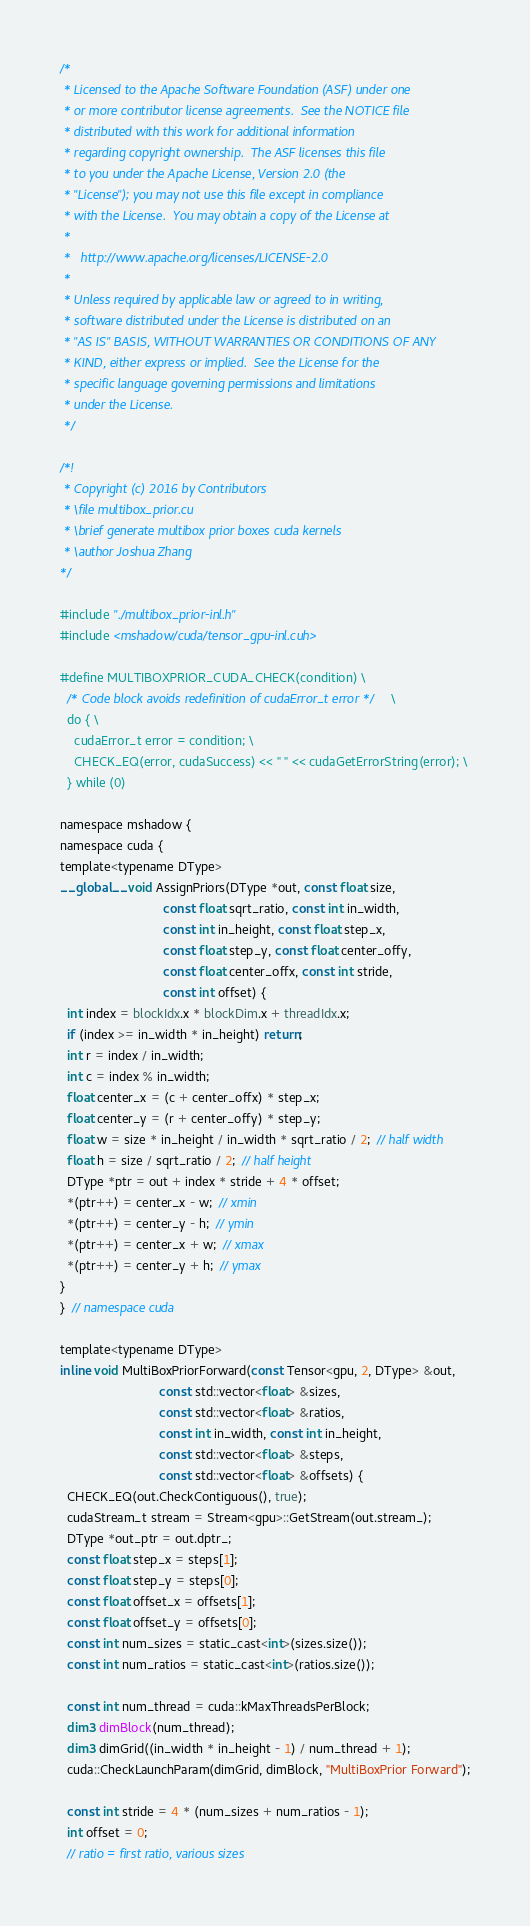Convert code to text. <code><loc_0><loc_0><loc_500><loc_500><_Cuda_>/*
 * Licensed to the Apache Software Foundation (ASF) under one
 * or more contributor license agreements.  See the NOTICE file
 * distributed with this work for additional information
 * regarding copyright ownership.  The ASF licenses this file
 * to you under the Apache License, Version 2.0 (the
 * "License"); you may not use this file except in compliance
 * with the License.  You may obtain a copy of the License at
 *
 *   http://www.apache.org/licenses/LICENSE-2.0
 *
 * Unless required by applicable law or agreed to in writing,
 * software distributed under the License is distributed on an
 * "AS IS" BASIS, WITHOUT WARRANTIES OR CONDITIONS OF ANY
 * KIND, either express or implied.  See the License for the
 * specific language governing permissions and limitations
 * under the License.
 */

/*!
 * Copyright (c) 2016 by Contributors
 * \file multibox_prior.cu
 * \brief generate multibox prior boxes cuda kernels
 * \author Joshua Zhang
*/

#include "./multibox_prior-inl.h"
#include <mshadow/cuda/tensor_gpu-inl.cuh>

#define MULTIBOXPRIOR_CUDA_CHECK(condition) \
  /* Code block avoids redefinition of cudaError_t error */ \
  do { \
    cudaError_t error = condition; \
    CHECK_EQ(error, cudaSuccess) << " " << cudaGetErrorString(error); \
  } while (0)

namespace mshadow {
namespace cuda {
template<typename DType>
__global__ void AssignPriors(DType *out, const float size,
                             const float sqrt_ratio, const int in_width,
                             const int in_height, const float step_x,
                             const float step_y, const float center_offy,
                             const float center_offx, const int stride,
                             const int offset) {
  int index = blockIdx.x * blockDim.x + threadIdx.x;
  if (index >= in_width * in_height) return;
  int r = index / in_width;
  int c = index % in_width;
  float center_x = (c + center_offx) * step_x;
  float center_y = (r + center_offy) * step_y;
  float w = size * in_height / in_width * sqrt_ratio / 2;  // half width
  float h = size / sqrt_ratio / 2;  // half height
  DType *ptr = out + index * stride + 4 * offset;
  *(ptr++) = center_x - w;  // xmin
  *(ptr++) = center_y - h;  // ymin
  *(ptr++) = center_x + w;  // xmax
  *(ptr++) = center_y + h;  // ymax
}
}  // namespace cuda

template<typename DType>
inline void MultiBoxPriorForward(const Tensor<gpu, 2, DType> &out,
                            const std::vector<float> &sizes,
                            const std::vector<float> &ratios,
                            const int in_width, const int in_height,
                            const std::vector<float> &steps,
                            const std::vector<float> &offsets) {
  CHECK_EQ(out.CheckContiguous(), true);
  cudaStream_t stream = Stream<gpu>::GetStream(out.stream_);
  DType *out_ptr = out.dptr_;
  const float step_x = steps[1];
  const float step_y = steps[0];
  const float offset_x = offsets[1];
  const float offset_y = offsets[0];
  const int num_sizes = static_cast<int>(sizes.size());
  const int num_ratios = static_cast<int>(ratios.size());

  const int num_thread = cuda::kMaxThreadsPerBlock;
  dim3 dimBlock(num_thread);
  dim3 dimGrid((in_width * in_height - 1) / num_thread + 1);
  cuda::CheckLaunchParam(dimGrid, dimBlock, "MultiBoxPrior Forward");

  const int stride = 4 * (num_sizes + num_ratios - 1);
  int offset = 0;
  // ratio = first ratio, various sizes</code> 